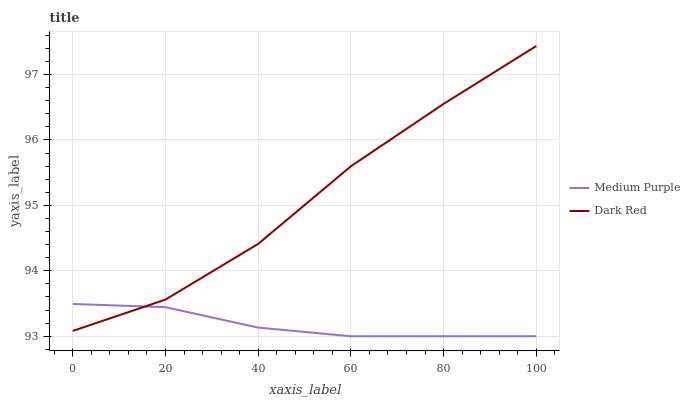Does Dark Red have the minimum area under the curve?
Answer yes or no. No. Is Dark Red the smoothest?
Answer yes or no. No. Does Dark Red have the lowest value?
Answer yes or no. No. 